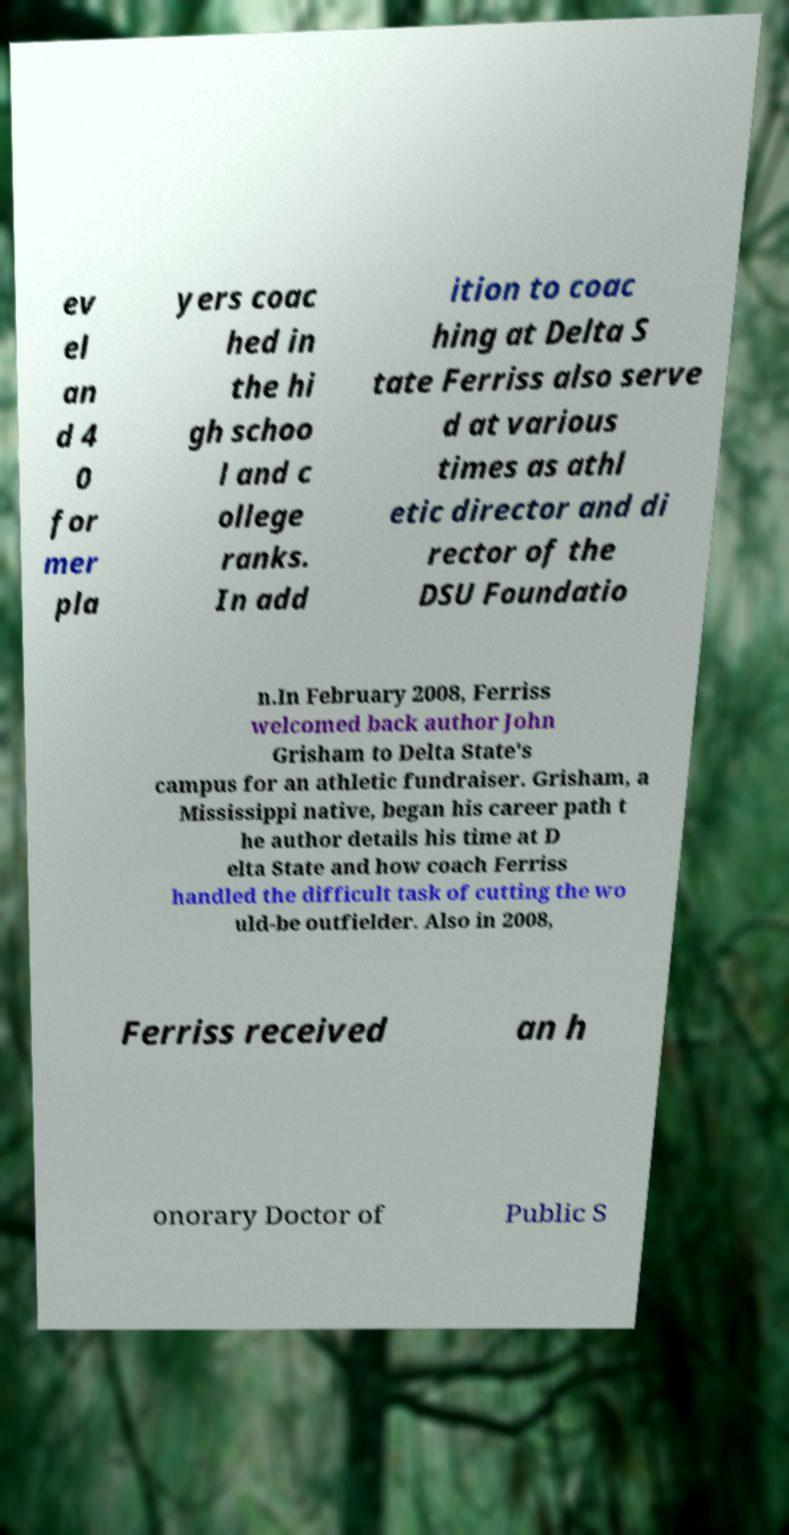What messages or text are displayed in this image? I need them in a readable, typed format. ev el an d 4 0 for mer pla yers coac hed in the hi gh schoo l and c ollege ranks. In add ition to coac hing at Delta S tate Ferriss also serve d at various times as athl etic director and di rector of the DSU Foundatio n.In February 2008, Ferriss welcomed back author John Grisham to Delta State's campus for an athletic fundraiser. Grisham, a Mississippi native, began his career path t he author details his time at D elta State and how coach Ferriss handled the difficult task of cutting the wo uld-be outfielder. Also in 2008, Ferriss received an h onorary Doctor of Public S 